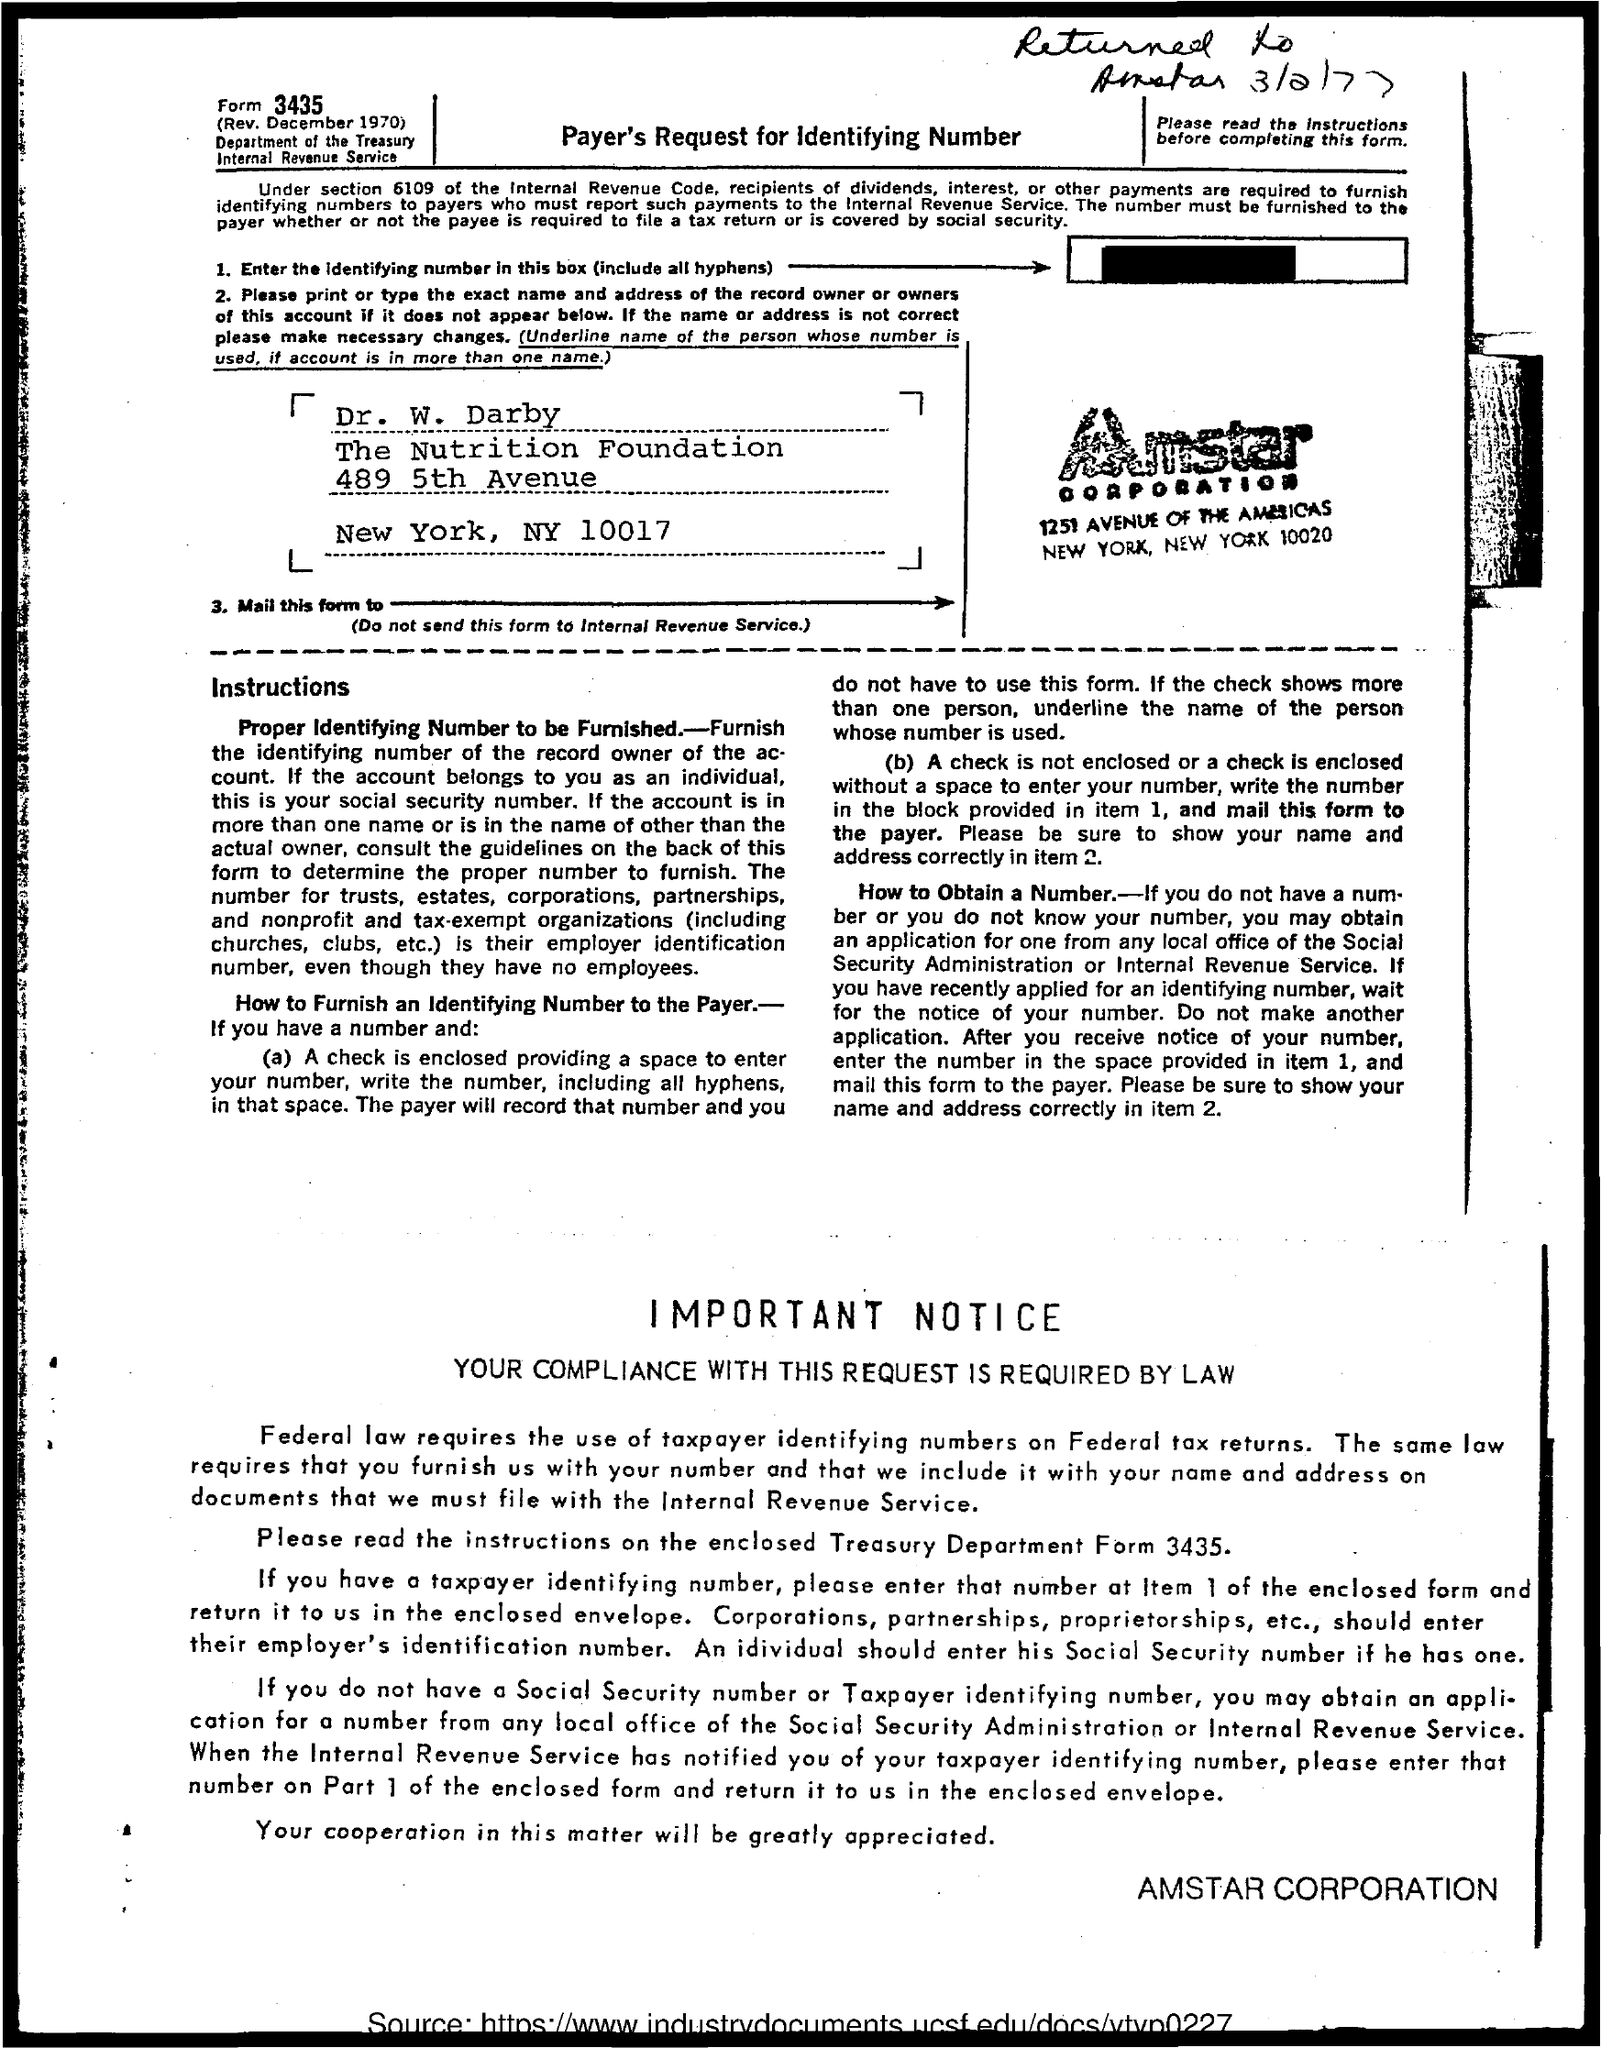Outline some significant characteristics in this image. The form number is 3435. The title of the document is Payer's Request for Identifying Number. I, [Your Name], do hereby declare that the name of the corporation is Amstar Corporation. 